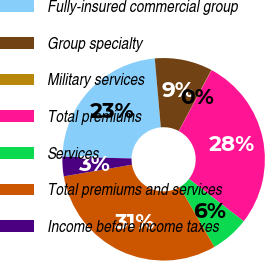Convert chart. <chart><loc_0><loc_0><loc_500><loc_500><pie_chart><fcel>Fully-insured commercial group<fcel>Group specialty<fcel>Military services<fcel>Total premiums<fcel>Services<fcel>Total premiums and services<fcel>Income before income taxes<nl><fcel>23.19%<fcel>9.21%<fcel>0.05%<fcel>27.61%<fcel>6.16%<fcel>30.67%<fcel>3.11%<nl></chart> 